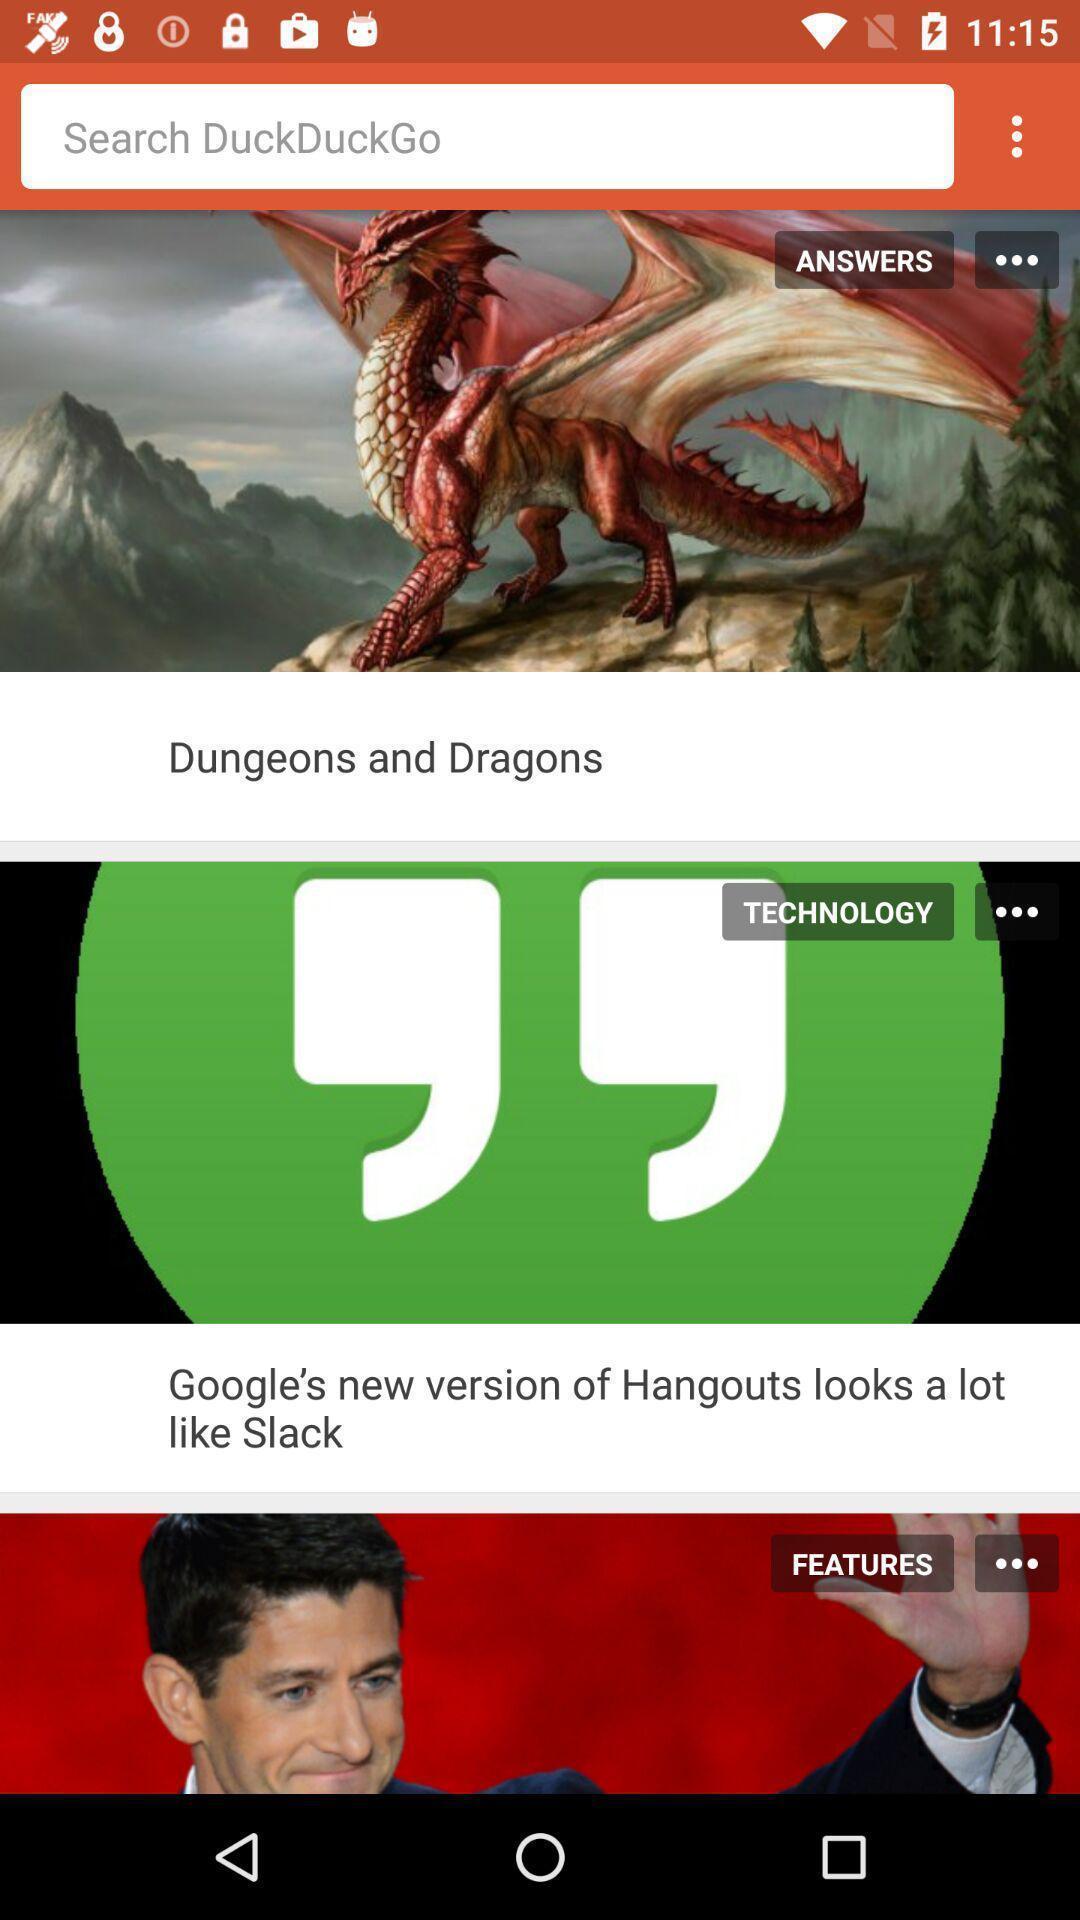Summarize the main components in this picture. Screen shows different options. 